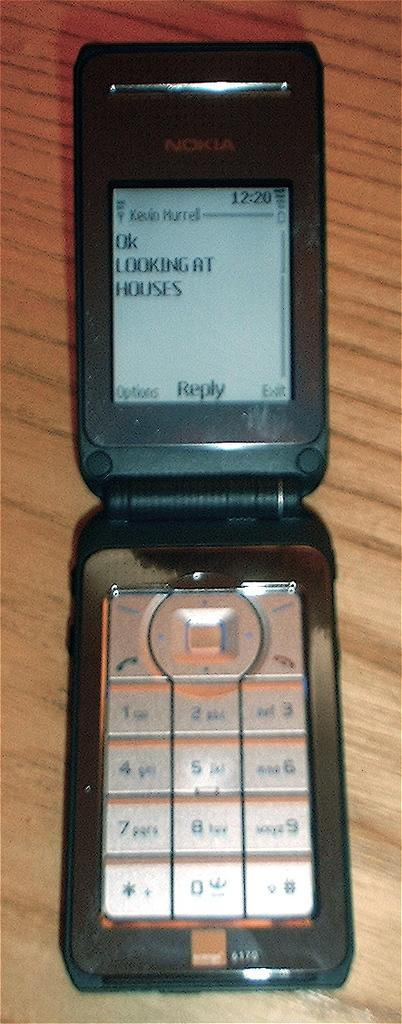<image>
Provide a brief description of the given image. A Nokia cell phone screen with the message that Kevin is looking at houses. 